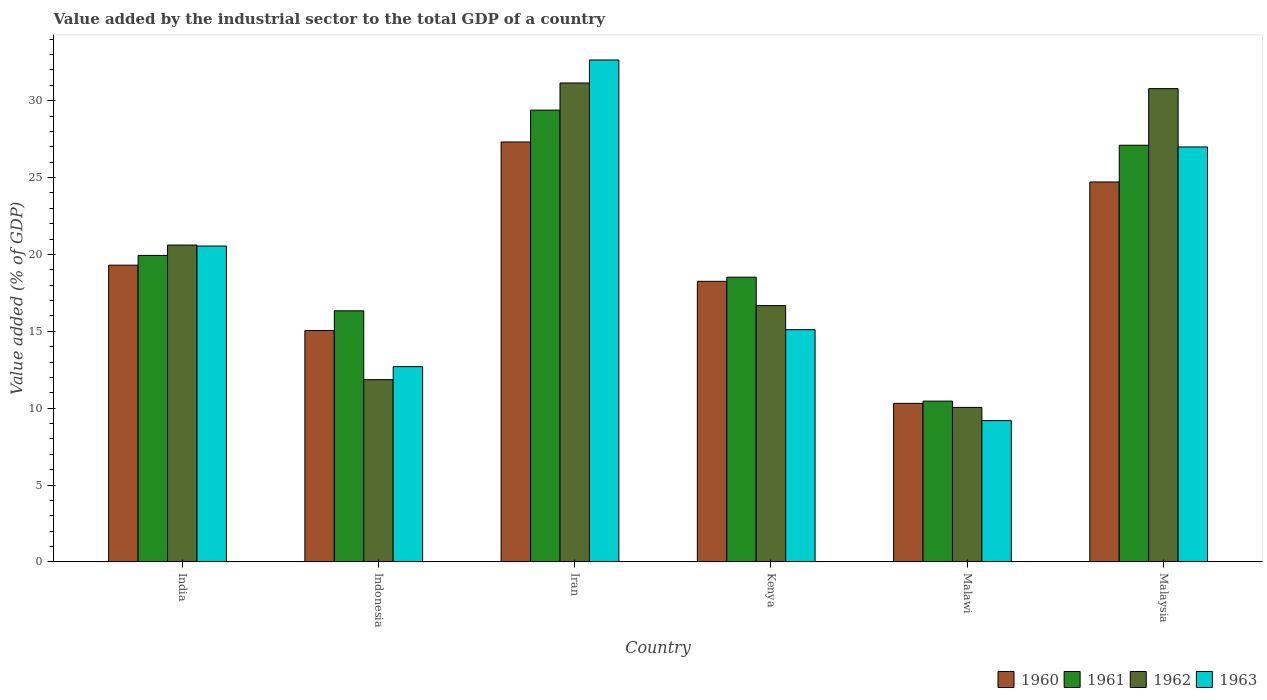How many different coloured bars are there?
Give a very brief answer. 4. How many bars are there on the 1st tick from the left?
Provide a succinct answer. 4. What is the label of the 4th group of bars from the left?
Offer a very short reply. Kenya. In how many cases, is the number of bars for a given country not equal to the number of legend labels?
Ensure brevity in your answer.  0. What is the value added by the industrial sector to the total GDP in 1963 in Kenya?
Your answer should be very brief. 15.1. Across all countries, what is the maximum value added by the industrial sector to the total GDP in 1963?
Give a very brief answer. 32.65. Across all countries, what is the minimum value added by the industrial sector to the total GDP in 1962?
Provide a succinct answer. 10.05. In which country was the value added by the industrial sector to the total GDP in 1960 maximum?
Your answer should be compact. Iran. In which country was the value added by the industrial sector to the total GDP in 1961 minimum?
Make the answer very short. Malawi. What is the total value added by the industrial sector to the total GDP in 1963 in the graph?
Keep it short and to the point. 117.17. What is the difference between the value added by the industrial sector to the total GDP in 1961 in India and that in Malaysia?
Provide a succinct answer. -7.17. What is the difference between the value added by the industrial sector to the total GDP in 1960 in Indonesia and the value added by the industrial sector to the total GDP in 1963 in Malaysia?
Your answer should be very brief. -11.94. What is the average value added by the industrial sector to the total GDP in 1960 per country?
Give a very brief answer. 19.16. What is the difference between the value added by the industrial sector to the total GDP of/in 1961 and value added by the industrial sector to the total GDP of/in 1962 in Indonesia?
Offer a terse response. 4.48. In how many countries, is the value added by the industrial sector to the total GDP in 1963 greater than 32 %?
Your answer should be very brief. 1. What is the ratio of the value added by the industrial sector to the total GDP in 1960 in India to that in Malawi?
Offer a very short reply. 1.87. Is the value added by the industrial sector to the total GDP in 1963 in India less than that in Kenya?
Your answer should be compact. No. Is the difference between the value added by the industrial sector to the total GDP in 1961 in Iran and Kenya greater than the difference between the value added by the industrial sector to the total GDP in 1962 in Iran and Kenya?
Offer a very short reply. No. What is the difference between the highest and the second highest value added by the industrial sector to the total GDP in 1961?
Provide a succinct answer. -7.17. What is the difference between the highest and the lowest value added by the industrial sector to the total GDP in 1961?
Make the answer very short. 18.93. In how many countries, is the value added by the industrial sector to the total GDP in 1960 greater than the average value added by the industrial sector to the total GDP in 1960 taken over all countries?
Offer a very short reply. 3. What does the 2nd bar from the left in Kenya represents?
Ensure brevity in your answer.  1961. What does the 4th bar from the right in Indonesia represents?
Your response must be concise. 1960. How many countries are there in the graph?
Provide a short and direct response. 6. Does the graph contain grids?
Make the answer very short. No. How are the legend labels stacked?
Make the answer very short. Horizontal. What is the title of the graph?
Keep it short and to the point. Value added by the industrial sector to the total GDP of a country. Does "2009" appear as one of the legend labels in the graph?
Provide a short and direct response. No. What is the label or title of the Y-axis?
Provide a succinct answer. Value added (% of GDP). What is the Value added (% of GDP) of 1960 in India?
Offer a very short reply. 19.3. What is the Value added (% of GDP) in 1961 in India?
Offer a terse response. 19.93. What is the Value added (% of GDP) in 1962 in India?
Keep it short and to the point. 20.61. What is the Value added (% of GDP) of 1963 in India?
Provide a short and direct response. 20.54. What is the Value added (% of GDP) of 1960 in Indonesia?
Ensure brevity in your answer.  15.05. What is the Value added (% of GDP) of 1961 in Indonesia?
Offer a very short reply. 16.33. What is the Value added (% of GDP) in 1962 in Indonesia?
Keep it short and to the point. 11.85. What is the Value added (% of GDP) of 1963 in Indonesia?
Your response must be concise. 12.7. What is the Value added (% of GDP) in 1960 in Iran?
Keep it short and to the point. 27.31. What is the Value added (% of GDP) in 1961 in Iran?
Your answer should be compact. 29.38. What is the Value added (% of GDP) of 1962 in Iran?
Make the answer very short. 31.15. What is the Value added (% of GDP) in 1963 in Iran?
Give a very brief answer. 32.65. What is the Value added (% of GDP) of 1960 in Kenya?
Offer a very short reply. 18.25. What is the Value added (% of GDP) in 1961 in Kenya?
Make the answer very short. 18.52. What is the Value added (% of GDP) of 1962 in Kenya?
Make the answer very short. 16.67. What is the Value added (% of GDP) in 1963 in Kenya?
Provide a succinct answer. 15.1. What is the Value added (% of GDP) in 1960 in Malawi?
Offer a terse response. 10.31. What is the Value added (% of GDP) of 1961 in Malawi?
Your answer should be compact. 10.46. What is the Value added (% of GDP) in 1962 in Malawi?
Ensure brevity in your answer.  10.05. What is the Value added (% of GDP) in 1963 in Malawi?
Your response must be concise. 9.19. What is the Value added (% of GDP) in 1960 in Malaysia?
Make the answer very short. 24.71. What is the Value added (% of GDP) of 1961 in Malaysia?
Your answer should be very brief. 27.1. What is the Value added (% of GDP) in 1962 in Malaysia?
Provide a short and direct response. 30.78. What is the Value added (% of GDP) in 1963 in Malaysia?
Offer a very short reply. 26.99. Across all countries, what is the maximum Value added (% of GDP) in 1960?
Make the answer very short. 27.31. Across all countries, what is the maximum Value added (% of GDP) in 1961?
Your answer should be very brief. 29.38. Across all countries, what is the maximum Value added (% of GDP) of 1962?
Give a very brief answer. 31.15. Across all countries, what is the maximum Value added (% of GDP) of 1963?
Offer a terse response. 32.65. Across all countries, what is the minimum Value added (% of GDP) of 1960?
Your answer should be compact. 10.31. Across all countries, what is the minimum Value added (% of GDP) of 1961?
Keep it short and to the point. 10.46. Across all countries, what is the minimum Value added (% of GDP) of 1962?
Offer a terse response. 10.05. Across all countries, what is the minimum Value added (% of GDP) in 1963?
Your answer should be very brief. 9.19. What is the total Value added (% of GDP) of 1960 in the graph?
Offer a terse response. 114.93. What is the total Value added (% of GDP) of 1961 in the graph?
Provide a short and direct response. 121.72. What is the total Value added (% of GDP) in 1962 in the graph?
Your response must be concise. 121.11. What is the total Value added (% of GDP) of 1963 in the graph?
Ensure brevity in your answer.  117.17. What is the difference between the Value added (% of GDP) of 1960 in India and that in Indonesia?
Give a very brief answer. 4.25. What is the difference between the Value added (% of GDP) in 1961 in India and that in Indonesia?
Offer a very short reply. 3.6. What is the difference between the Value added (% of GDP) of 1962 in India and that in Indonesia?
Ensure brevity in your answer.  8.76. What is the difference between the Value added (% of GDP) of 1963 in India and that in Indonesia?
Provide a succinct answer. 7.84. What is the difference between the Value added (% of GDP) in 1960 in India and that in Iran?
Your answer should be compact. -8.01. What is the difference between the Value added (% of GDP) of 1961 in India and that in Iran?
Offer a terse response. -9.45. What is the difference between the Value added (% of GDP) in 1962 in India and that in Iran?
Your answer should be very brief. -10.54. What is the difference between the Value added (% of GDP) in 1963 in India and that in Iran?
Your response must be concise. -12.1. What is the difference between the Value added (% of GDP) of 1960 in India and that in Kenya?
Your response must be concise. 1.05. What is the difference between the Value added (% of GDP) of 1961 in India and that in Kenya?
Make the answer very short. 1.42. What is the difference between the Value added (% of GDP) of 1962 in India and that in Kenya?
Your answer should be very brief. 3.94. What is the difference between the Value added (% of GDP) in 1963 in India and that in Kenya?
Provide a short and direct response. 5.44. What is the difference between the Value added (% of GDP) of 1960 in India and that in Malawi?
Offer a very short reply. 8.99. What is the difference between the Value added (% of GDP) of 1961 in India and that in Malawi?
Give a very brief answer. 9.48. What is the difference between the Value added (% of GDP) of 1962 in India and that in Malawi?
Provide a short and direct response. 10.56. What is the difference between the Value added (% of GDP) of 1963 in India and that in Malawi?
Give a very brief answer. 11.36. What is the difference between the Value added (% of GDP) in 1960 in India and that in Malaysia?
Give a very brief answer. -5.41. What is the difference between the Value added (% of GDP) in 1961 in India and that in Malaysia?
Offer a very short reply. -7.17. What is the difference between the Value added (% of GDP) in 1962 in India and that in Malaysia?
Provide a short and direct response. -10.17. What is the difference between the Value added (% of GDP) in 1963 in India and that in Malaysia?
Give a very brief answer. -6.45. What is the difference between the Value added (% of GDP) in 1960 in Indonesia and that in Iran?
Make the answer very short. -12.26. What is the difference between the Value added (% of GDP) in 1961 in Indonesia and that in Iran?
Ensure brevity in your answer.  -13.05. What is the difference between the Value added (% of GDP) of 1962 in Indonesia and that in Iran?
Your answer should be very brief. -19.3. What is the difference between the Value added (% of GDP) of 1963 in Indonesia and that in Iran?
Your answer should be compact. -19.95. What is the difference between the Value added (% of GDP) in 1960 in Indonesia and that in Kenya?
Your answer should be very brief. -3.2. What is the difference between the Value added (% of GDP) in 1961 in Indonesia and that in Kenya?
Provide a succinct answer. -2.19. What is the difference between the Value added (% of GDP) in 1962 in Indonesia and that in Kenya?
Keep it short and to the point. -4.82. What is the difference between the Value added (% of GDP) in 1963 in Indonesia and that in Kenya?
Offer a terse response. -2.4. What is the difference between the Value added (% of GDP) in 1960 in Indonesia and that in Malawi?
Your answer should be compact. 4.74. What is the difference between the Value added (% of GDP) of 1961 in Indonesia and that in Malawi?
Ensure brevity in your answer.  5.87. What is the difference between the Value added (% of GDP) in 1962 in Indonesia and that in Malawi?
Offer a very short reply. 1.8. What is the difference between the Value added (% of GDP) of 1963 in Indonesia and that in Malawi?
Offer a very short reply. 3.51. What is the difference between the Value added (% of GDP) in 1960 in Indonesia and that in Malaysia?
Your answer should be very brief. -9.66. What is the difference between the Value added (% of GDP) in 1961 in Indonesia and that in Malaysia?
Make the answer very short. -10.77. What is the difference between the Value added (% of GDP) of 1962 in Indonesia and that in Malaysia?
Offer a very short reply. -18.93. What is the difference between the Value added (% of GDP) of 1963 in Indonesia and that in Malaysia?
Offer a terse response. -14.29. What is the difference between the Value added (% of GDP) in 1960 in Iran and that in Kenya?
Offer a terse response. 9.06. What is the difference between the Value added (% of GDP) of 1961 in Iran and that in Kenya?
Make the answer very short. 10.87. What is the difference between the Value added (% of GDP) of 1962 in Iran and that in Kenya?
Give a very brief answer. 14.48. What is the difference between the Value added (% of GDP) of 1963 in Iran and that in Kenya?
Make the answer very short. 17.54. What is the difference between the Value added (% of GDP) in 1960 in Iran and that in Malawi?
Offer a terse response. 17. What is the difference between the Value added (% of GDP) in 1961 in Iran and that in Malawi?
Offer a very short reply. 18.93. What is the difference between the Value added (% of GDP) of 1962 in Iran and that in Malawi?
Make the answer very short. 21.1. What is the difference between the Value added (% of GDP) of 1963 in Iran and that in Malawi?
Keep it short and to the point. 23.46. What is the difference between the Value added (% of GDP) in 1960 in Iran and that in Malaysia?
Provide a succinct answer. 2.6. What is the difference between the Value added (% of GDP) in 1961 in Iran and that in Malaysia?
Provide a succinct answer. 2.29. What is the difference between the Value added (% of GDP) of 1962 in Iran and that in Malaysia?
Give a very brief answer. 0.37. What is the difference between the Value added (% of GDP) of 1963 in Iran and that in Malaysia?
Your answer should be very brief. 5.66. What is the difference between the Value added (% of GDP) of 1960 in Kenya and that in Malawi?
Offer a very short reply. 7.94. What is the difference between the Value added (% of GDP) of 1961 in Kenya and that in Malawi?
Ensure brevity in your answer.  8.06. What is the difference between the Value added (% of GDP) in 1962 in Kenya and that in Malawi?
Provide a short and direct response. 6.62. What is the difference between the Value added (% of GDP) of 1963 in Kenya and that in Malawi?
Your answer should be compact. 5.92. What is the difference between the Value added (% of GDP) in 1960 in Kenya and that in Malaysia?
Keep it short and to the point. -6.46. What is the difference between the Value added (% of GDP) in 1961 in Kenya and that in Malaysia?
Your answer should be very brief. -8.58. What is the difference between the Value added (% of GDP) in 1962 in Kenya and that in Malaysia?
Your response must be concise. -14.11. What is the difference between the Value added (% of GDP) in 1963 in Kenya and that in Malaysia?
Make the answer very short. -11.88. What is the difference between the Value added (% of GDP) in 1960 in Malawi and that in Malaysia?
Provide a succinct answer. -14.4. What is the difference between the Value added (% of GDP) of 1961 in Malawi and that in Malaysia?
Give a very brief answer. -16.64. What is the difference between the Value added (% of GDP) in 1962 in Malawi and that in Malaysia?
Ensure brevity in your answer.  -20.73. What is the difference between the Value added (% of GDP) in 1963 in Malawi and that in Malaysia?
Ensure brevity in your answer.  -17.8. What is the difference between the Value added (% of GDP) in 1960 in India and the Value added (% of GDP) in 1961 in Indonesia?
Provide a short and direct response. 2.97. What is the difference between the Value added (% of GDP) of 1960 in India and the Value added (% of GDP) of 1962 in Indonesia?
Keep it short and to the point. 7.45. What is the difference between the Value added (% of GDP) in 1960 in India and the Value added (% of GDP) in 1963 in Indonesia?
Provide a short and direct response. 6.6. What is the difference between the Value added (% of GDP) in 1961 in India and the Value added (% of GDP) in 1962 in Indonesia?
Give a very brief answer. 8.08. What is the difference between the Value added (% of GDP) of 1961 in India and the Value added (% of GDP) of 1963 in Indonesia?
Make the answer very short. 7.23. What is the difference between the Value added (% of GDP) in 1962 in India and the Value added (% of GDP) in 1963 in Indonesia?
Your answer should be very brief. 7.91. What is the difference between the Value added (% of GDP) of 1960 in India and the Value added (% of GDP) of 1961 in Iran?
Make the answer very short. -10.09. What is the difference between the Value added (% of GDP) in 1960 in India and the Value added (% of GDP) in 1962 in Iran?
Give a very brief answer. -11.85. What is the difference between the Value added (% of GDP) of 1960 in India and the Value added (% of GDP) of 1963 in Iran?
Offer a terse response. -13.35. What is the difference between the Value added (% of GDP) of 1961 in India and the Value added (% of GDP) of 1962 in Iran?
Give a very brief answer. -11.22. What is the difference between the Value added (% of GDP) of 1961 in India and the Value added (% of GDP) of 1963 in Iran?
Keep it short and to the point. -12.71. What is the difference between the Value added (% of GDP) of 1962 in India and the Value added (% of GDP) of 1963 in Iran?
Keep it short and to the point. -12.04. What is the difference between the Value added (% of GDP) of 1960 in India and the Value added (% of GDP) of 1961 in Kenya?
Keep it short and to the point. 0.78. What is the difference between the Value added (% of GDP) in 1960 in India and the Value added (% of GDP) in 1962 in Kenya?
Ensure brevity in your answer.  2.63. What is the difference between the Value added (% of GDP) of 1960 in India and the Value added (% of GDP) of 1963 in Kenya?
Make the answer very short. 4.2. What is the difference between the Value added (% of GDP) in 1961 in India and the Value added (% of GDP) in 1962 in Kenya?
Your response must be concise. 3.26. What is the difference between the Value added (% of GDP) in 1961 in India and the Value added (% of GDP) in 1963 in Kenya?
Offer a very short reply. 4.83. What is the difference between the Value added (% of GDP) of 1962 in India and the Value added (% of GDP) of 1963 in Kenya?
Give a very brief answer. 5.5. What is the difference between the Value added (% of GDP) of 1960 in India and the Value added (% of GDP) of 1961 in Malawi?
Give a very brief answer. 8.84. What is the difference between the Value added (% of GDP) of 1960 in India and the Value added (% of GDP) of 1962 in Malawi?
Make the answer very short. 9.25. What is the difference between the Value added (% of GDP) in 1960 in India and the Value added (% of GDP) in 1963 in Malawi?
Provide a short and direct response. 10.11. What is the difference between the Value added (% of GDP) in 1961 in India and the Value added (% of GDP) in 1962 in Malawi?
Offer a terse response. 9.89. What is the difference between the Value added (% of GDP) of 1961 in India and the Value added (% of GDP) of 1963 in Malawi?
Your answer should be compact. 10.75. What is the difference between the Value added (% of GDP) in 1962 in India and the Value added (% of GDP) in 1963 in Malawi?
Provide a short and direct response. 11.42. What is the difference between the Value added (% of GDP) in 1960 in India and the Value added (% of GDP) in 1961 in Malaysia?
Your answer should be compact. -7.8. What is the difference between the Value added (% of GDP) of 1960 in India and the Value added (% of GDP) of 1962 in Malaysia?
Provide a short and direct response. -11.48. What is the difference between the Value added (% of GDP) in 1960 in India and the Value added (% of GDP) in 1963 in Malaysia?
Give a very brief answer. -7.69. What is the difference between the Value added (% of GDP) in 1961 in India and the Value added (% of GDP) in 1962 in Malaysia?
Provide a succinct answer. -10.85. What is the difference between the Value added (% of GDP) of 1961 in India and the Value added (% of GDP) of 1963 in Malaysia?
Your answer should be very brief. -7.06. What is the difference between the Value added (% of GDP) in 1962 in India and the Value added (% of GDP) in 1963 in Malaysia?
Provide a short and direct response. -6.38. What is the difference between the Value added (% of GDP) in 1960 in Indonesia and the Value added (% of GDP) in 1961 in Iran?
Provide a succinct answer. -14.34. What is the difference between the Value added (% of GDP) of 1960 in Indonesia and the Value added (% of GDP) of 1962 in Iran?
Keep it short and to the point. -16.1. What is the difference between the Value added (% of GDP) of 1960 in Indonesia and the Value added (% of GDP) of 1963 in Iran?
Your answer should be very brief. -17.6. What is the difference between the Value added (% of GDP) of 1961 in Indonesia and the Value added (% of GDP) of 1962 in Iran?
Offer a very short reply. -14.82. What is the difference between the Value added (% of GDP) of 1961 in Indonesia and the Value added (% of GDP) of 1963 in Iran?
Provide a succinct answer. -16.32. What is the difference between the Value added (% of GDP) of 1962 in Indonesia and the Value added (% of GDP) of 1963 in Iran?
Ensure brevity in your answer.  -20.79. What is the difference between the Value added (% of GDP) of 1960 in Indonesia and the Value added (% of GDP) of 1961 in Kenya?
Provide a succinct answer. -3.47. What is the difference between the Value added (% of GDP) in 1960 in Indonesia and the Value added (% of GDP) in 1962 in Kenya?
Make the answer very short. -1.62. What is the difference between the Value added (% of GDP) in 1960 in Indonesia and the Value added (% of GDP) in 1963 in Kenya?
Offer a very short reply. -0.06. What is the difference between the Value added (% of GDP) of 1961 in Indonesia and the Value added (% of GDP) of 1962 in Kenya?
Ensure brevity in your answer.  -0.34. What is the difference between the Value added (% of GDP) of 1961 in Indonesia and the Value added (% of GDP) of 1963 in Kenya?
Provide a short and direct response. 1.23. What is the difference between the Value added (% of GDP) of 1962 in Indonesia and the Value added (% of GDP) of 1963 in Kenya?
Your response must be concise. -3.25. What is the difference between the Value added (% of GDP) in 1960 in Indonesia and the Value added (% of GDP) in 1961 in Malawi?
Your response must be concise. 4.59. What is the difference between the Value added (% of GDP) of 1960 in Indonesia and the Value added (% of GDP) of 1962 in Malawi?
Keep it short and to the point. 5. What is the difference between the Value added (% of GDP) of 1960 in Indonesia and the Value added (% of GDP) of 1963 in Malawi?
Offer a terse response. 5.86. What is the difference between the Value added (% of GDP) of 1961 in Indonesia and the Value added (% of GDP) of 1962 in Malawi?
Give a very brief answer. 6.28. What is the difference between the Value added (% of GDP) of 1961 in Indonesia and the Value added (% of GDP) of 1963 in Malawi?
Ensure brevity in your answer.  7.14. What is the difference between the Value added (% of GDP) of 1962 in Indonesia and the Value added (% of GDP) of 1963 in Malawi?
Give a very brief answer. 2.66. What is the difference between the Value added (% of GDP) in 1960 in Indonesia and the Value added (% of GDP) in 1961 in Malaysia?
Your response must be concise. -12.05. What is the difference between the Value added (% of GDP) of 1960 in Indonesia and the Value added (% of GDP) of 1962 in Malaysia?
Give a very brief answer. -15.73. What is the difference between the Value added (% of GDP) of 1960 in Indonesia and the Value added (% of GDP) of 1963 in Malaysia?
Your response must be concise. -11.94. What is the difference between the Value added (% of GDP) in 1961 in Indonesia and the Value added (% of GDP) in 1962 in Malaysia?
Ensure brevity in your answer.  -14.45. What is the difference between the Value added (% of GDP) of 1961 in Indonesia and the Value added (% of GDP) of 1963 in Malaysia?
Keep it short and to the point. -10.66. What is the difference between the Value added (% of GDP) of 1962 in Indonesia and the Value added (% of GDP) of 1963 in Malaysia?
Provide a succinct answer. -15.14. What is the difference between the Value added (% of GDP) of 1960 in Iran and the Value added (% of GDP) of 1961 in Kenya?
Offer a terse response. 8.79. What is the difference between the Value added (% of GDP) in 1960 in Iran and the Value added (% of GDP) in 1962 in Kenya?
Ensure brevity in your answer.  10.64. What is the difference between the Value added (% of GDP) in 1960 in Iran and the Value added (% of GDP) in 1963 in Kenya?
Provide a succinct answer. 12.21. What is the difference between the Value added (% of GDP) of 1961 in Iran and the Value added (% of GDP) of 1962 in Kenya?
Give a very brief answer. 12.71. What is the difference between the Value added (% of GDP) in 1961 in Iran and the Value added (% of GDP) in 1963 in Kenya?
Your answer should be very brief. 14.28. What is the difference between the Value added (% of GDP) of 1962 in Iran and the Value added (% of GDP) of 1963 in Kenya?
Your response must be concise. 16.04. What is the difference between the Value added (% of GDP) in 1960 in Iran and the Value added (% of GDP) in 1961 in Malawi?
Make the answer very short. 16.86. What is the difference between the Value added (% of GDP) of 1960 in Iran and the Value added (% of GDP) of 1962 in Malawi?
Ensure brevity in your answer.  17.26. What is the difference between the Value added (% of GDP) in 1960 in Iran and the Value added (% of GDP) in 1963 in Malawi?
Your answer should be compact. 18.12. What is the difference between the Value added (% of GDP) in 1961 in Iran and the Value added (% of GDP) in 1962 in Malawi?
Your answer should be compact. 19.34. What is the difference between the Value added (% of GDP) in 1961 in Iran and the Value added (% of GDP) in 1963 in Malawi?
Your answer should be very brief. 20.2. What is the difference between the Value added (% of GDP) in 1962 in Iran and the Value added (% of GDP) in 1963 in Malawi?
Ensure brevity in your answer.  21.96. What is the difference between the Value added (% of GDP) in 1960 in Iran and the Value added (% of GDP) in 1961 in Malaysia?
Offer a terse response. 0.21. What is the difference between the Value added (% of GDP) of 1960 in Iran and the Value added (% of GDP) of 1962 in Malaysia?
Offer a terse response. -3.47. What is the difference between the Value added (% of GDP) of 1960 in Iran and the Value added (% of GDP) of 1963 in Malaysia?
Provide a short and direct response. 0.32. What is the difference between the Value added (% of GDP) of 1961 in Iran and the Value added (% of GDP) of 1962 in Malaysia?
Provide a short and direct response. -1.4. What is the difference between the Value added (% of GDP) in 1961 in Iran and the Value added (% of GDP) in 1963 in Malaysia?
Offer a terse response. 2.4. What is the difference between the Value added (% of GDP) in 1962 in Iran and the Value added (% of GDP) in 1963 in Malaysia?
Your answer should be compact. 4.16. What is the difference between the Value added (% of GDP) of 1960 in Kenya and the Value added (% of GDP) of 1961 in Malawi?
Offer a terse response. 7.79. What is the difference between the Value added (% of GDP) of 1960 in Kenya and the Value added (% of GDP) of 1962 in Malawi?
Provide a short and direct response. 8.2. What is the difference between the Value added (% of GDP) in 1960 in Kenya and the Value added (% of GDP) in 1963 in Malawi?
Keep it short and to the point. 9.06. What is the difference between the Value added (% of GDP) of 1961 in Kenya and the Value added (% of GDP) of 1962 in Malawi?
Provide a short and direct response. 8.47. What is the difference between the Value added (% of GDP) of 1961 in Kenya and the Value added (% of GDP) of 1963 in Malawi?
Offer a very short reply. 9.33. What is the difference between the Value added (% of GDP) of 1962 in Kenya and the Value added (% of GDP) of 1963 in Malawi?
Offer a very short reply. 7.48. What is the difference between the Value added (% of GDP) of 1960 in Kenya and the Value added (% of GDP) of 1961 in Malaysia?
Keep it short and to the point. -8.85. What is the difference between the Value added (% of GDP) of 1960 in Kenya and the Value added (% of GDP) of 1962 in Malaysia?
Offer a terse response. -12.53. What is the difference between the Value added (% of GDP) of 1960 in Kenya and the Value added (% of GDP) of 1963 in Malaysia?
Provide a succinct answer. -8.74. What is the difference between the Value added (% of GDP) of 1961 in Kenya and the Value added (% of GDP) of 1962 in Malaysia?
Ensure brevity in your answer.  -12.26. What is the difference between the Value added (% of GDP) of 1961 in Kenya and the Value added (% of GDP) of 1963 in Malaysia?
Keep it short and to the point. -8.47. What is the difference between the Value added (% of GDP) in 1962 in Kenya and the Value added (% of GDP) in 1963 in Malaysia?
Your answer should be very brief. -10.32. What is the difference between the Value added (% of GDP) of 1960 in Malawi and the Value added (% of GDP) of 1961 in Malaysia?
Offer a very short reply. -16.79. What is the difference between the Value added (% of GDP) of 1960 in Malawi and the Value added (% of GDP) of 1962 in Malaysia?
Keep it short and to the point. -20.47. What is the difference between the Value added (% of GDP) in 1960 in Malawi and the Value added (% of GDP) in 1963 in Malaysia?
Offer a terse response. -16.68. What is the difference between the Value added (% of GDP) of 1961 in Malawi and the Value added (% of GDP) of 1962 in Malaysia?
Your answer should be very brief. -20.33. What is the difference between the Value added (% of GDP) in 1961 in Malawi and the Value added (% of GDP) in 1963 in Malaysia?
Make the answer very short. -16.53. What is the difference between the Value added (% of GDP) in 1962 in Malawi and the Value added (% of GDP) in 1963 in Malaysia?
Make the answer very short. -16.94. What is the average Value added (% of GDP) in 1960 per country?
Keep it short and to the point. 19.16. What is the average Value added (% of GDP) of 1961 per country?
Provide a succinct answer. 20.29. What is the average Value added (% of GDP) of 1962 per country?
Make the answer very short. 20.18. What is the average Value added (% of GDP) in 1963 per country?
Make the answer very short. 19.53. What is the difference between the Value added (% of GDP) in 1960 and Value added (% of GDP) in 1961 in India?
Ensure brevity in your answer.  -0.63. What is the difference between the Value added (% of GDP) of 1960 and Value added (% of GDP) of 1962 in India?
Offer a terse response. -1.31. What is the difference between the Value added (% of GDP) of 1960 and Value added (% of GDP) of 1963 in India?
Give a very brief answer. -1.24. What is the difference between the Value added (% of GDP) in 1961 and Value added (% of GDP) in 1962 in India?
Ensure brevity in your answer.  -0.68. What is the difference between the Value added (% of GDP) of 1961 and Value added (% of GDP) of 1963 in India?
Keep it short and to the point. -0.61. What is the difference between the Value added (% of GDP) in 1962 and Value added (% of GDP) in 1963 in India?
Give a very brief answer. 0.06. What is the difference between the Value added (% of GDP) in 1960 and Value added (% of GDP) in 1961 in Indonesia?
Make the answer very short. -1.28. What is the difference between the Value added (% of GDP) in 1960 and Value added (% of GDP) in 1962 in Indonesia?
Provide a short and direct response. 3.2. What is the difference between the Value added (% of GDP) in 1960 and Value added (% of GDP) in 1963 in Indonesia?
Offer a very short reply. 2.35. What is the difference between the Value added (% of GDP) of 1961 and Value added (% of GDP) of 1962 in Indonesia?
Your answer should be compact. 4.48. What is the difference between the Value added (% of GDP) of 1961 and Value added (% of GDP) of 1963 in Indonesia?
Keep it short and to the point. 3.63. What is the difference between the Value added (% of GDP) of 1962 and Value added (% of GDP) of 1963 in Indonesia?
Your answer should be compact. -0.85. What is the difference between the Value added (% of GDP) of 1960 and Value added (% of GDP) of 1961 in Iran?
Make the answer very short. -2.07. What is the difference between the Value added (% of GDP) of 1960 and Value added (% of GDP) of 1962 in Iran?
Your answer should be very brief. -3.84. What is the difference between the Value added (% of GDP) in 1960 and Value added (% of GDP) in 1963 in Iran?
Your answer should be very brief. -5.33. What is the difference between the Value added (% of GDP) of 1961 and Value added (% of GDP) of 1962 in Iran?
Provide a succinct answer. -1.76. What is the difference between the Value added (% of GDP) of 1961 and Value added (% of GDP) of 1963 in Iran?
Your answer should be compact. -3.26. What is the difference between the Value added (% of GDP) in 1962 and Value added (% of GDP) in 1963 in Iran?
Your response must be concise. -1.5. What is the difference between the Value added (% of GDP) in 1960 and Value added (% of GDP) in 1961 in Kenya?
Provide a succinct answer. -0.27. What is the difference between the Value added (% of GDP) in 1960 and Value added (% of GDP) in 1962 in Kenya?
Your response must be concise. 1.58. What is the difference between the Value added (% of GDP) of 1960 and Value added (% of GDP) of 1963 in Kenya?
Ensure brevity in your answer.  3.14. What is the difference between the Value added (% of GDP) of 1961 and Value added (% of GDP) of 1962 in Kenya?
Ensure brevity in your answer.  1.85. What is the difference between the Value added (% of GDP) in 1961 and Value added (% of GDP) in 1963 in Kenya?
Make the answer very short. 3.41. What is the difference between the Value added (% of GDP) of 1962 and Value added (% of GDP) of 1963 in Kenya?
Ensure brevity in your answer.  1.57. What is the difference between the Value added (% of GDP) in 1960 and Value added (% of GDP) in 1961 in Malawi?
Offer a very short reply. -0.15. What is the difference between the Value added (% of GDP) in 1960 and Value added (% of GDP) in 1962 in Malawi?
Your answer should be very brief. 0.26. What is the difference between the Value added (% of GDP) of 1960 and Value added (% of GDP) of 1963 in Malawi?
Provide a short and direct response. 1.12. What is the difference between the Value added (% of GDP) of 1961 and Value added (% of GDP) of 1962 in Malawi?
Offer a very short reply. 0.41. What is the difference between the Value added (% of GDP) in 1961 and Value added (% of GDP) in 1963 in Malawi?
Make the answer very short. 1.27. What is the difference between the Value added (% of GDP) of 1962 and Value added (% of GDP) of 1963 in Malawi?
Provide a succinct answer. 0.86. What is the difference between the Value added (% of GDP) in 1960 and Value added (% of GDP) in 1961 in Malaysia?
Offer a very short reply. -2.39. What is the difference between the Value added (% of GDP) of 1960 and Value added (% of GDP) of 1962 in Malaysia?
Give a very brief answer. -6.07. What is the difference between the Value added (% of GDP) of 1960 and Value added (% of GDP) of 1963 in Malaysia?
Offer a terse response. -2.28. What is the difference between the Value added (% of GDP) in 1961 and Value added (% of GDP) in 1962 in Malaysia?
Keep it short and to the point. -3.68. What is the difference between the Value added (% of GDP) in 1961 and Value added (% of GDP) in 1963 in Malaysia?
Your answer should be very brief. 0.11. What is the difference between the Value added (% of GDP) of 1962 and Value added (% of GDP) of 1963 in Malaysia?
Make the answer very short. 3.79. What is the ratio of the Value added (% of GDP) in 1960 in India to that in Indonesia?
Make the answer very short. 1.28. What is the ratio of the Value added (% of GDP) of 1961 in India to that in Indonesia?
Keep it short and to the point. 1.22. What is the ratio of the Value added (% of GDP) in 1962 in India to that in Indonesia?
Provide a short and direct response. 1.74. What is the ratio of the Value added (% of GDP) of 1963 in India to that in Indonesia?
Your answer should be very brief. 1.62. What is the ratio of the Value added (% of GDP) of 1960 in India to that in Iran?
Keep it short and to the point. 0.71. What is the ratio of the Value added (% of GDP) of 1961 in India to that in Iran?
Provide a succinct answer. 0.68. What is the ratio of the Value added (% of GDP) of 1962 in India to that in Iran?
Ensure brevity in your answer.  0.66. What is the ratio of the Value added (% of GDP) of 1963 in India to that in Iran?
Provide a succinct answer. 0.63. What is the ratio of the Value added (% of GDP) in 1960 in India to that in Kenya?
Ensure brevity in your answer.  1.06. What is the ratio of the Value added (% of GDP) of 1961 in India to that in Kenya?
Your answer should be very brief. 1.08. What is the ratio of the Value added (% of GDP) in 1962 in India to that in Kenya?
Give a very brief answer. 1.24. What is the ratio of the Value added (% of GDP) of 1963 in India to that in Kenya?
Provide a succinct answer. 1.36. What is the ratio of the Value added (% of GDP) in 1960 in India to that in Malawi?
Ensure brevity in your answer.  1.87. What is the ratio of the Value added (% of GDP) in 1961 in India to that in Malawi?
Your response must be concise. 1.91. What is the ratio of the Value added (% of GDP) in 1962 in India to that in Malawi?
Give a very brief answer. 2.05. What is the ratio of the Value added (% of GDP) in 1963 in India to that in Malawi?
Offer a terse response. 2.24. What is the ratio of the Value added (% of GDP) in 1960 in India to that in Malaysia?
Offer a terse response. 0.78. What is the ratio of the Value added (% of GDP) in 1961 in India to that in Malaysia?
Make the answer very short. 0.74. What is the ratio of the Value added (% of GDP) in 1962 in India to that in Malaysia?
Ensure brevity in your answer.  0.67. What is the ratio of the Value added (% of GDP) of 1963 in India to that in Malaysia?
Your answer should be compact. 0.76. What is the ratio of the Value added (% of GDP) of 1960 in Indonesia to that in Iran?
Your answer should be compact. 0.55. What is the ratio of the Value added (% of GDP) in 1961 in Indonesia to that in Iran?
Provide a succinct answer. 0.56. What is the ratio of the Value added (% of GDP) of 1962 in Indonesia to that in Iran?
Your answer should be compact. 0.38. What is the ratio of the Value added (% of GDP) in 1963 in Indonesia to that in Iran?
Your answer should be compact. 0.39. What is the ratio of the Value added (% of GDP) in 1960 in Indonesia to that in Kenya?
Keep it short and to the point. 0.82. What is the ratio of the Value added (% of GDP) in 1961 in Indonesia to that in Kenya?
Your answer should be very brief. 0.88. What is the ratio of the Value added (% of GDP) of 1962 in Indonesia to that in Kenya?
Your response must be concise. 0.71. What is the ratio of the Value added (% of GDP) of 1963 in Indonesia to that in Kenya?
Offer a very short reply. 0.84. What is the ratio of the Value added (% of GDP) in 1960 in Indonesia to that in Malawi?
Make the answer very short. 1.46. What is the ratio of the Value added (% of GDP) in 1961 in Indonesia to that in Malawi?
Your response must be concise. 1.56. What is the ratio of the Value added (% of GDP) in 1962 in Indonesia to that in Malawi?
Your answer should be very brief. 1.18. What is the ratio of the Value added (% of GDP) of 1963 in Indonesia to that in Malawi?
Ensure brevity in your answer.  1.38. What is the ratio of the Value added (% of GDP) of 1960 in Indonesia to that in Malaysia?
Give a very brief answer. 0.61. What is the ratio of the Value added (% of GDP) of 1961 in Indonesia to that in Malaysia?
Your answer should be very brief. 0.6. What is the ratio of the Value added (% of GDP) in 1962 in Indonesia to that in Malaysia?
Ensure brevity in your answer.  0.39. What is the ratio of the Value added (% of GDP) of 1963 in Indonesia to that in Malaysia?
Give a very brief answer. 0.47. What is the ratio of the Value added (% of GDP) of 1960 in Iran to that in Kenya?
Give a very brief answer. 1.5. What is the ratio of the Value added (% of GDP) of 1961 in Iran to that in Kenya?
Provide a short and direct response. 1.59. What is the ratio of the Value added (% of GDP) of 1962 in Iran to that in Kenya?
Your answer should be very brief. 1.87. What is the ratio of the Value added (% of GDP) in 1963 in Iran to that in Kenya?
Make the answer very short. 2.16. What is the ratio of the Value added (% of GDP) of 1960 in Iran to that in Malawi?
Offer a very short reply. 2.65. What is the ratio of the Value added (% of GDP) in 1961 in Iran to that in Malawi?
Give a very brief answer. 2.81. What is the ratio of the Value added (% of GDP) of 1962 in Iran to that in Malawi?
Provide a succinct answer. 3.1. What is the ratio of the Value added (% of GDP) of 1963 in Iran to that in Malawi?
Offer a very short reply. 3.55. What is the ratio of the Value added (% of GDP) in 1960 in Iran to that in Malaysia?
Your answer should be compact. 1.11. What is the ratio of the Value added (% of GDP) of 1961 in Iran to that in Malaysia?
Your response must be concise. 1.08. What is the ratio of the Value added (% of GDP) in 1962 in Iran to that in Malaysia?
Your answer should be very brief. 1.01. What is the ratio of the Value added (% of GDP) in 1963 in Iran to that in Malaysia?
Make the answer very short. 1.21. What is the ratio of the Value added (% of GDP) in 1960 in Kenya to that in Malawi?
Offer a very short reply. 1.77. What is the ratio of the Value added (% of GDP) of 1961 in Kenya to that in Malawi?
Your answer should be very brief. 1.77. What is the ratio of the Value added (% of GDP) of 1962 in Kenya to that in Malawi?
Your answer should be compact. 1.66. What is the ratio of the Value added (% of GDP) in 1963 in Kenya to that in Malawi?
Keep it short and to the point. 1.64. What is the ratio of the Value added (% of GDP) of 1960 in Kenya to that in Malaysia?
Offer a terse response. 0.74. What is the ratio of the Value added (% of GDP) of 1961 in Kenya to that in Malaysia?
Your answer should be compact. 0.68. What is the ratio of the Value added (% of GDP) of 1962 in Kenya to that in Malaysia?
Your answer should be compact. 0.54. What is the ratio of the Value added (% of GDP) of 1963 in Kenya to that in Malaysia?
Your answer should be very brief. 0.56. What is the ratio of the Value added (% of GDP) of 1960 in Malawi to that in Malaysia?
Offer a terse response. 0.42. What is the ratio of the Value added (% of GDP) in 1961 in Malawi to that in Malaysia?
Make the answer very short. 0.39. What is the ratio of the Value added (% of GDP) of 1962 in Malawi to that in Malaysia?
Offer a terse response. 0.33. What is the ratio of the Value added (% of GDP) of 1963 in Malawi to that in Malaysia?
Your response must be concise. 0.34. What is the difference between the highest and the second highest Value added (% of GDP) in 1960?
Make the answer very short. 2.6. What is the difference between the highest and the second highest Value added (% of GDP) in 1961?
Your answer should be very brief. 2.29. What is the difference between the highest and the second highest Value added (% of GDP) of 1962?
Offer a terse response. 0.37. What is the difference between the highest and the second highest Value added (% of GDP) in 1963?
Provide a short and direct response. 5.66. What is the difference between the highest and the lowest Value added (% of GDP) in 1960?
Offer a terse response. 17. What is the difference between the highest and the lowest Value added (% of GDP) in 1961?
Offer a very short reply. 18.93. What is the difference between the highest and the lowest Value added (% of GDP) of 1962?
Offer a terse response. 21.1. What is the difference between the highest and the lowest Value added (% of GDP) of 1963?
Give a very brief answer. 23.46. 